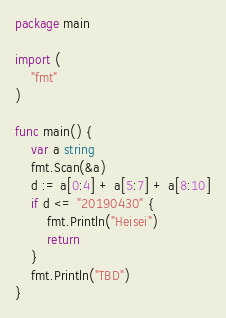Convert code to text. <code><loc_0><loc_0><loc_500><loc_500><_Go_>package main

import (
	"fmt"
)

func main() {
	var a string
	fmt.Scan(&a)
	d := a[0:4] + a[5:7] + a[8:10]
	if d <= "20190430" {
		fmt.Println("Heisei")
		return
	}
	fmt.Println("TBD")
}
</code> 